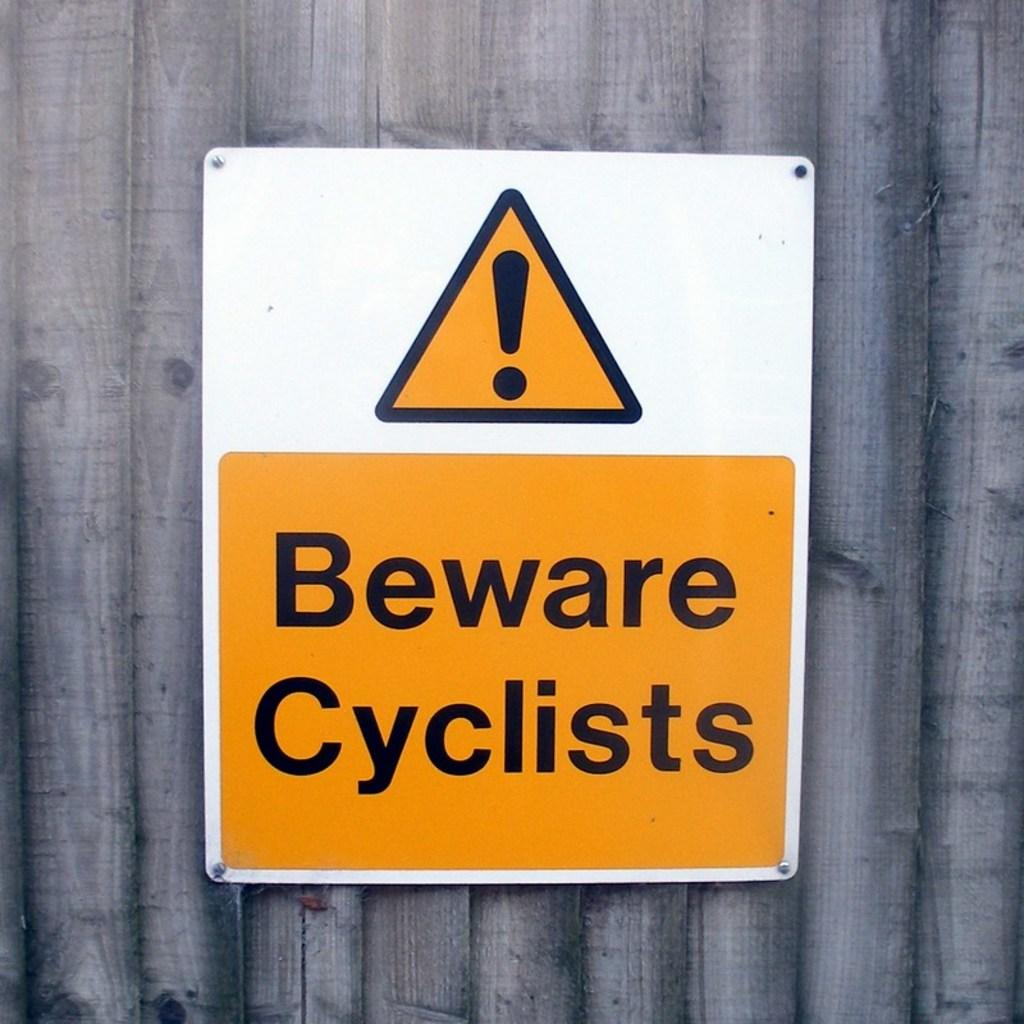<image>
Summarize the visual content of the image. Big orange, black, and white sign that says beware cyclists 